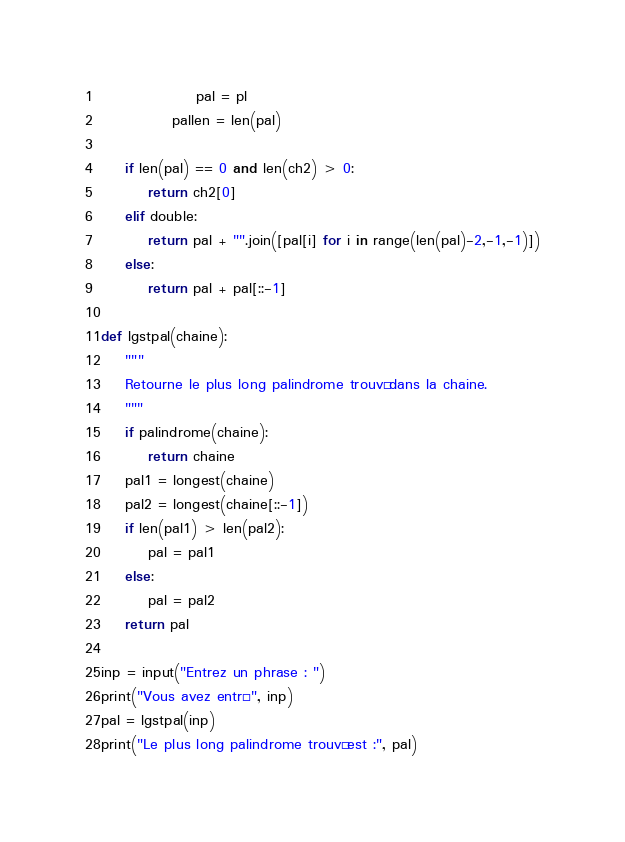Convert code to text. <code><loc_0><loc_0><loc_500><loc_500><_Python_>                pal = pl
            pallen = len(pal)

    if len(pal) == 0 and len(ch2) > 0:
        return ch2[0]
    elif double:
        return pal + "".join([pal[i] for i in range(len(pal)-2,-1,-1)])
    else:
        return pal + pal[::-1]

def lgstpal(chaine):
    """
    Retourne le plus long palindrome trouvé dans la chaine.
    """
    if palindrome(chaine):
        return chaine
    pal1 = longest(chaine)
    pal2 = longest(chaine[::-1])
    if len(pal1) > len(pal2):
        pal = pal1
    else:
        pal = pal2
    return pal

inp = input("Entrez un phrase : ")
print("Vous avez entré", inp)
pal = lgstpal(inp)
print("Le plus long palindrome trouvé est :", pal)

</code> 